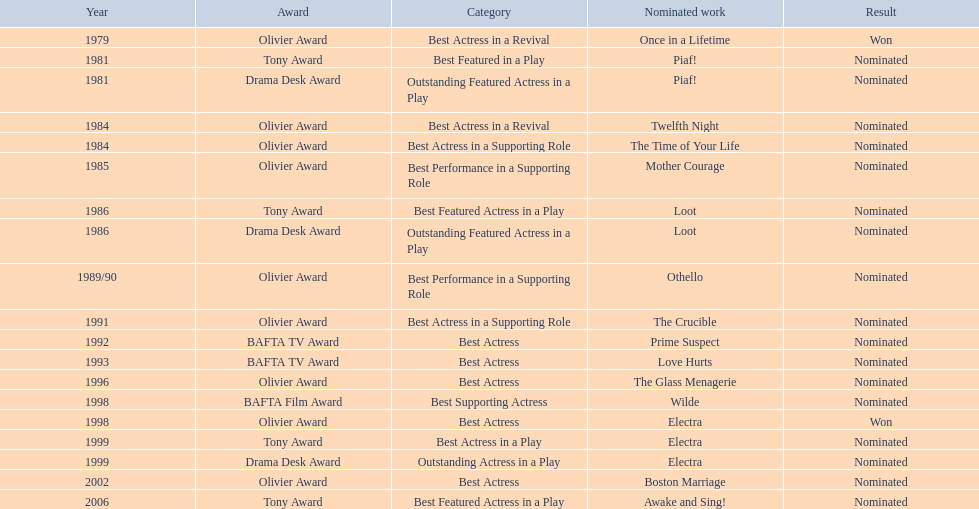What year did prime suspects receive a bafta tv award nomination? 1992. 